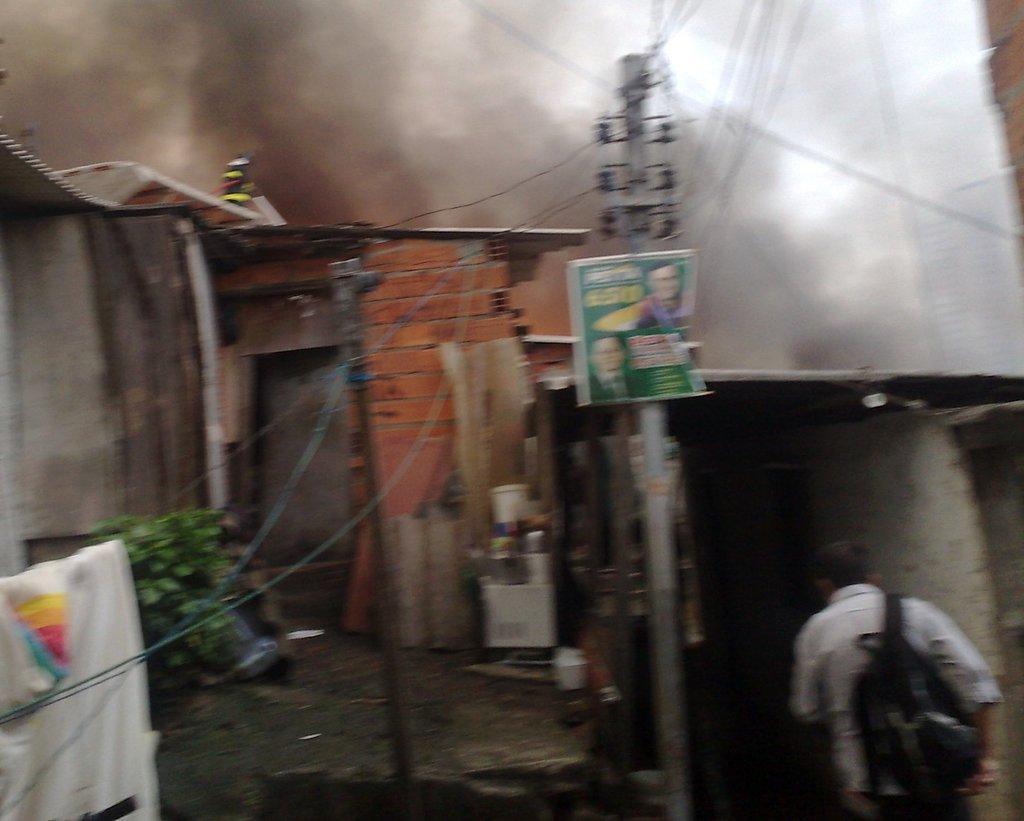Please provide a concise description of this image. In this image I can see an electric pole, wires, houses and a person on the road. At the top I can see a smoke. This image is taken may be in the evening. 